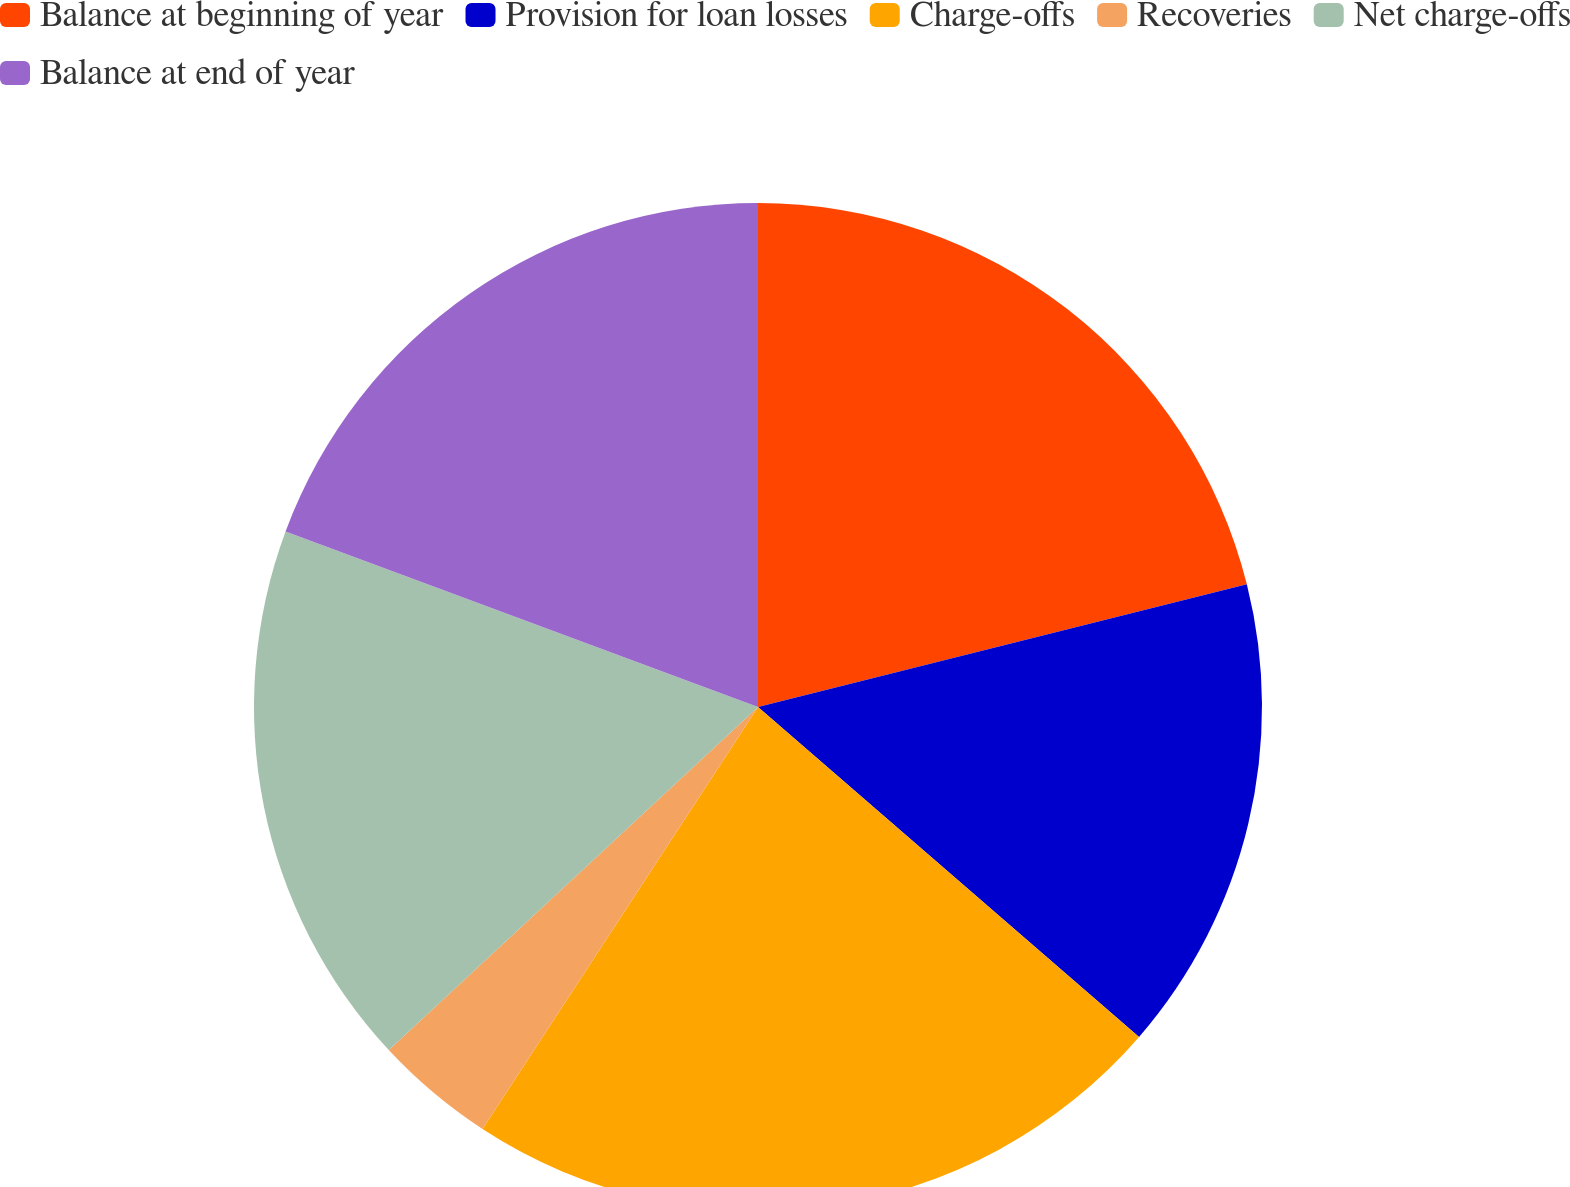Convert chart to OTSL. <chart><loc_0><loc_0><loc_500><loc_500><pie_chart><fcel>Balance at beginning of year<fcel>Provision for loan losses<fcel>Charge-offs<fcel>Recoveries<fcel>Net charge-offs<fcel>Balance at end of year<nl><fcel>21.09%<fcel>15.27%<fcel>22.85%<fcel>3.88%<fcel>17.58%<fcel>19.34%<nl></chart> 